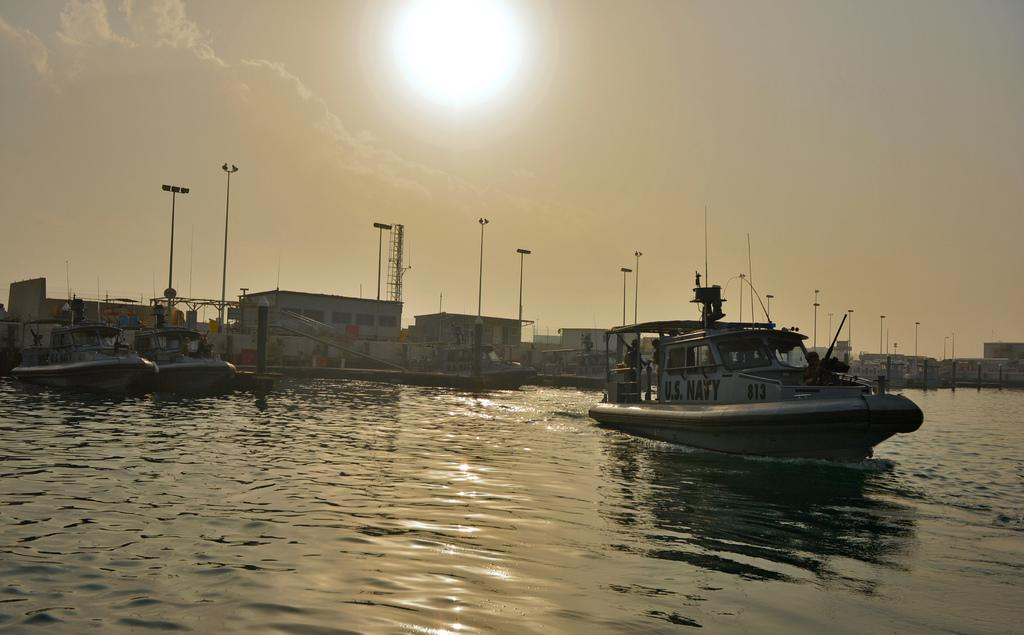What is on the water in the image? There are ships on the water in the image. What else can be seen in the image besides the ships? There are buildings visible in the image, as well as light poles. What is visible in the background of the image? The sky is visible in the background of the image. Can the sun be seen in the sky? Yes, the sun is observable in the sky. What language is spoken by the ship in the image? There is no indication that the ship is speaking a language in the image. Where is the birth certificate of the ship located in the image? There is no ship's birth certificate present in the image. 